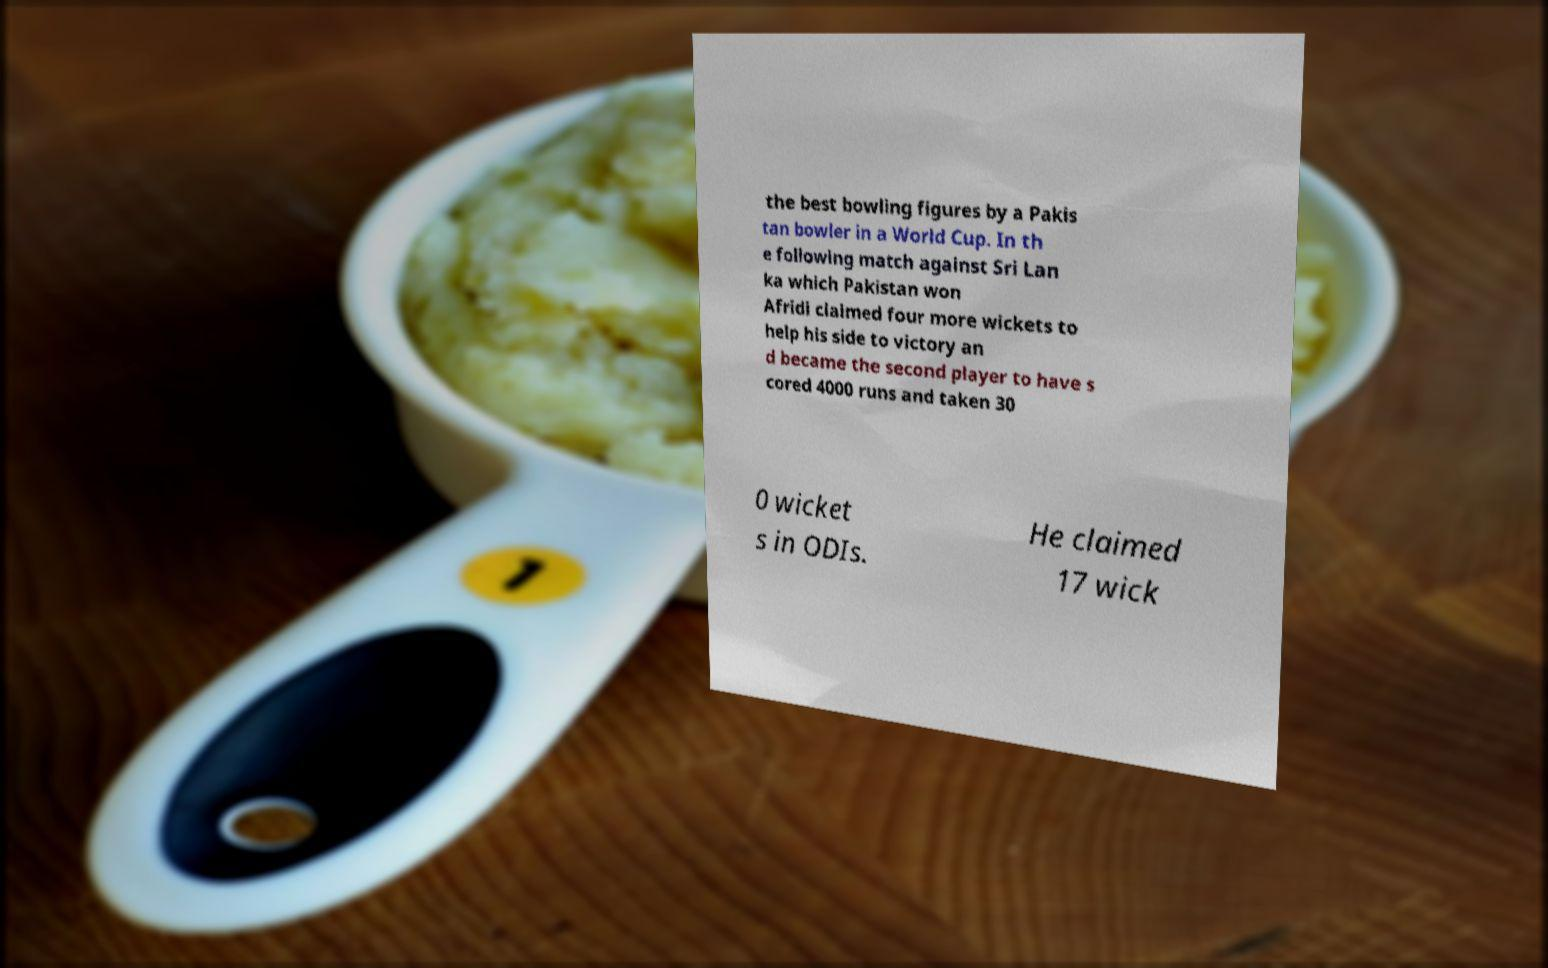For documentation purposes, I need the text within this image transcribed. Could you provide that? the best bowling figures by a Pakis tan bowler in a World Cup. In th e following match against Sri Lan ka which Pakistan won Afridi claimed four more wickets to help his side to victory an d became the second player to have s cored 4000 runs and taken 30 0 wicket s in ODIs. He claimed 17 wick 